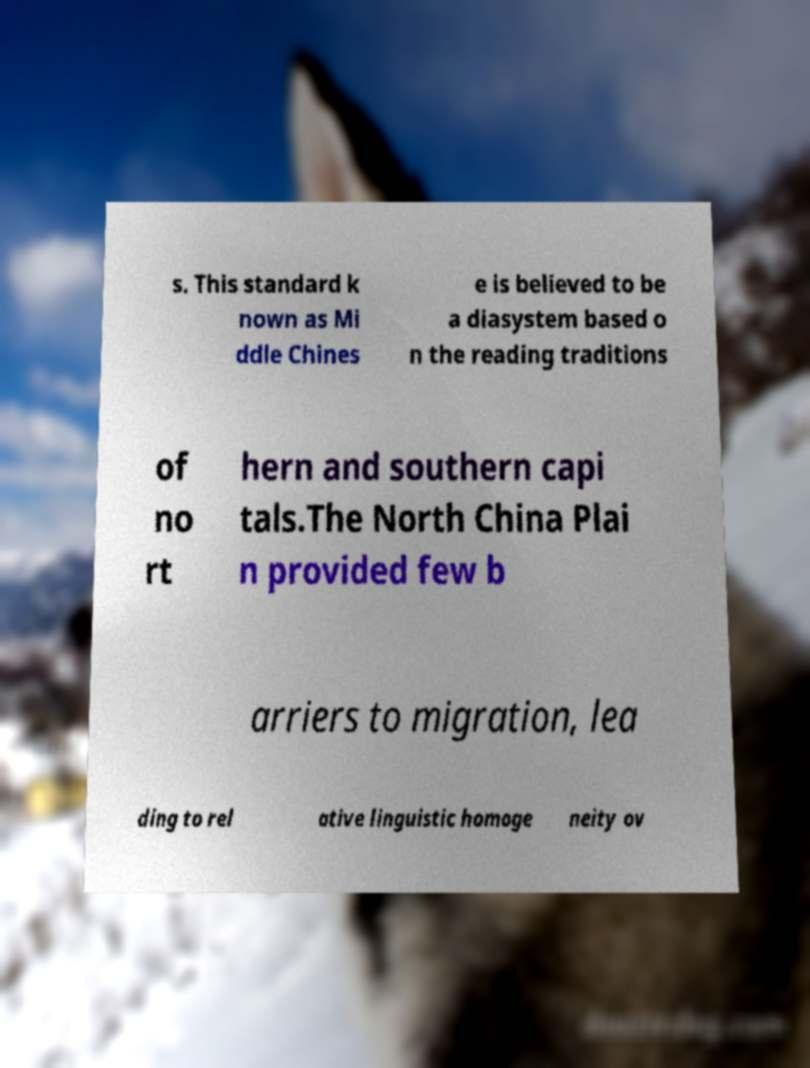Could you assist in decoding the text presented in this image and type it out clearly? s. This standard k nown as Mi ddle Chines e is believed to be a diasystem based o n the reading traditions of no rt hern and southern capi tals.The North China Plai n provided few b arriers to migration, lea ding to rel ative linguistic homoge neity ov 